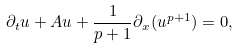<formula> <loc_0><loc_0><loc_500><loc_500>\partial _ { t } u + A u + \frac { 1 } { p + 1 } \partial _ { x } ( u ^ { p + 1 } ) = 0 ,</formula> 